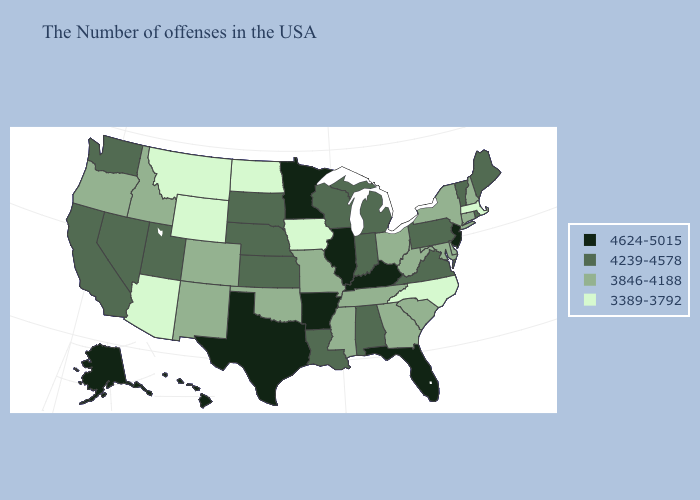Among the states that border Utah , which have the lowest value?
Short answer required. Wyoming, Arizona. Does Maine have a higher value than Wyoming?
Short answer required. Yes. Name the states that have a value in the range 4239-4578?
Quick response, please. Maine, Rhode Island, Vermont, Pennsylvania, Virginia, Michigan, Indiana, Alabama, Wisconsin, Louisiana, Kansas, Nebraska, South Dakota, Utah, Nevada, California, Washington. What is the lowest value in the Northeast?
Quick response, please. 3389-3792. Name the states that have a value in the range 4624-5015?
Quick response, please. New Jersey, Florida, Kentucky, Illinois, Arkansas, Minnesota, Texas, Alaska, Hawaii. Which states have the highest value in the USA?
Short answer required. New Jersey, Florida, Kentucky, Illinois, Arkansas, Minnesota, Texas, Alaska, Hawaii. Among the states that border Maine , which have the highest value?
Be succinct. New Hampshire. Name the states that have a value in the range 3846-4188?
Answer briefly. New Hampshire, Connecticut, New York, Delaware, Maryland, South Carolina, West Virginia, Ohio, Georgia, Tennessee, Mississippi, Missouri, Oklahoma, Colorado, New Mexico, Idaho, Oregon. What is the value of South Carolina?
Be succinct. 3846-4188. Which states have the highest value in the USA?
Write a very short answer. New Jersey, Florida, Kentucky, Illinois, Arkansas, Minnesota, Texas, Alaska, Hawaii. Name the states that have a value in the range 4624-5015?
Give a very brief answer. New Jersey, Florida, Kentucky, Illinois, Arkansas, Minnesota, Texas, Alaska, Hawaii. Does Oklahoma have the highest value in the South?
Short answer required. No. Which states hav the highest value in the MidWest?
Short answer required. Illinois, Minnesota. Does the first symbol in the legend represent the smallest category?
Give a very brief answer. No. What is the value of Hawaii?
Be succinct. 4624-5015. 